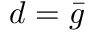<formula> <loc_0><loc_0><loc_500><loc_500>d = \bar { g }</formula> 